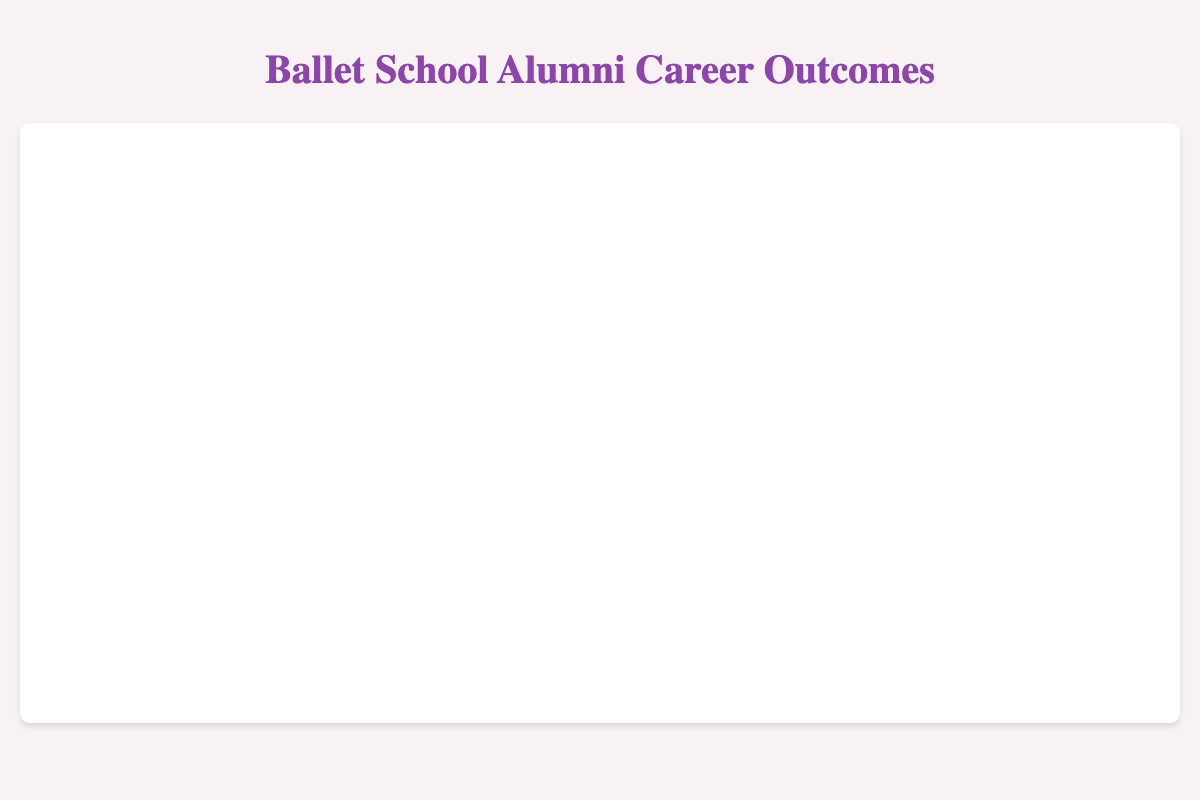What is the title of the figure? The title of the figure can be found at the top of the visualization. It states the main purpose of the chart.
Answer: Ballet School Alumni Career Outcomes How many alumni are shown in the figure? Count the number of individual bubbles in the chart. Each bubble corresponds to one alumni.
Answer: 9 What do the colors of the bubbles represent? The legend at the side of the chart indicates the color coding. Each color represents an initial role.
Answer: Initial roles (Corps de Ballet and Soloist) Who has the highest performance frequency? Look for the largest bubble in terms of size. The tooltip or label on hover shows the exact performance frequency. The largest bubble corresponds to Misty Copeland.
Answer: Misty Copeland Which alumni started in the Corps de Ballet and are now Principal Dancers? Identify the initial role for each bubble using color coding, and check the tooltip or labels on hover for the current role.
Answer: Anna Pavlova, Rudolf Nureyev, Friedemann Vogel, Darci Kistler, Johan Kobborg What is the range of performance frequencies among the alumni? Find the minimum and maximum bubble sizes. The tooltips give the exact performance frequencies. The range is from the smallest to the largest values.
Answer: 100 to 220 Compare the performance frequencies of alumni from the Royal Ballet School and the Royal Danish Ballet School. Who performed more frequently? Find the bubbles corresponding to these two schools by looking at the tooltip information. Compare the performance frequencies indicated in those tooltips. Anna Pavlova from the Royal Ballet School has 150, and Johan Kobborg from the Royal Danish Ballet School has 140.
Answer: Anna Pavlova What is the average performance frequency of the alumni who started as Soloists? Identify the bubbles for Soloists using the color coding. Note their performance frequencies and calculate the average: (180 + 220 + 170 + 160) / 4 = 182.5.
Answer: 182.5 How many alumni achieved the role of Principal Dancer? Check the tooltip or labels for the "Current Role" for each bubble. Count how many have the role "Principal Dancer".
Answer: 8 Which initial role generally leads to higher performance frequencies: Corps de Ballet or Soloist? Compare the performance frequencies of alumni based on the initial role colors. Observe which color (Corps de Ballet or Soloist) has larger bubbles on average.
Answer: Soloist 